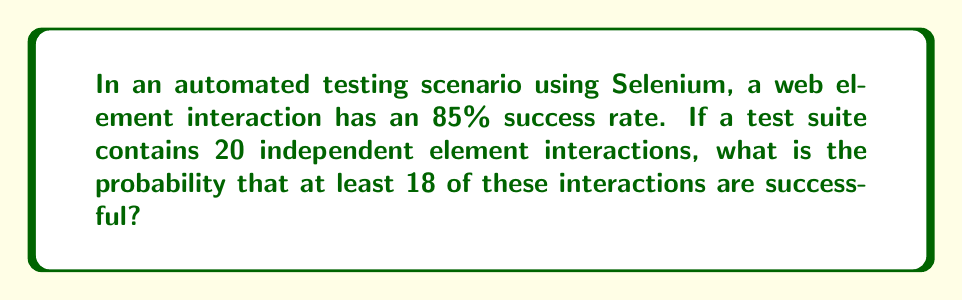Teach me how to tackle this problem. Let's approach this step-by-step:

1) This scenario follows a binomial distribution, where each interaction is an independent trial with a success probability of 0.85.

2) We need to find $P(X \geq 18)$, where $X$ is the number of successful interactions.

3) This is equivalent to $1 - P(X \leq 17)$, as the sum of all probabilities must equal 1.

4) The probability mass function for a binomial distribution is:

   $$P(X = k) = \binom{n}{k} p^k (1-p)^{n-k}$$

   where $n$ is the number of trials, $k$ is the number of successes, and $p$ is the probability of success on each trial.

5) In this case, $n = 20$, $p = 0.85$, and we need to sum this for $k = 0$ to $17$:

   $$P(X \leq 17) = \sum_{k=0}^{17} \binom{20}{k} (0.85)^k (0.15)^{20-k}$$

6) Calculating this sum:

   $$P(X \leq 17) \approx 0.0592$$

7) Therefore, the probability of at least 18 successes is:

   $$P(X \geq 18) = 1 - P(X \leq 17) \approx 1 - 0.0592 = 0.9408$$
Answer: $0.9408$ or $94.08\%$ 